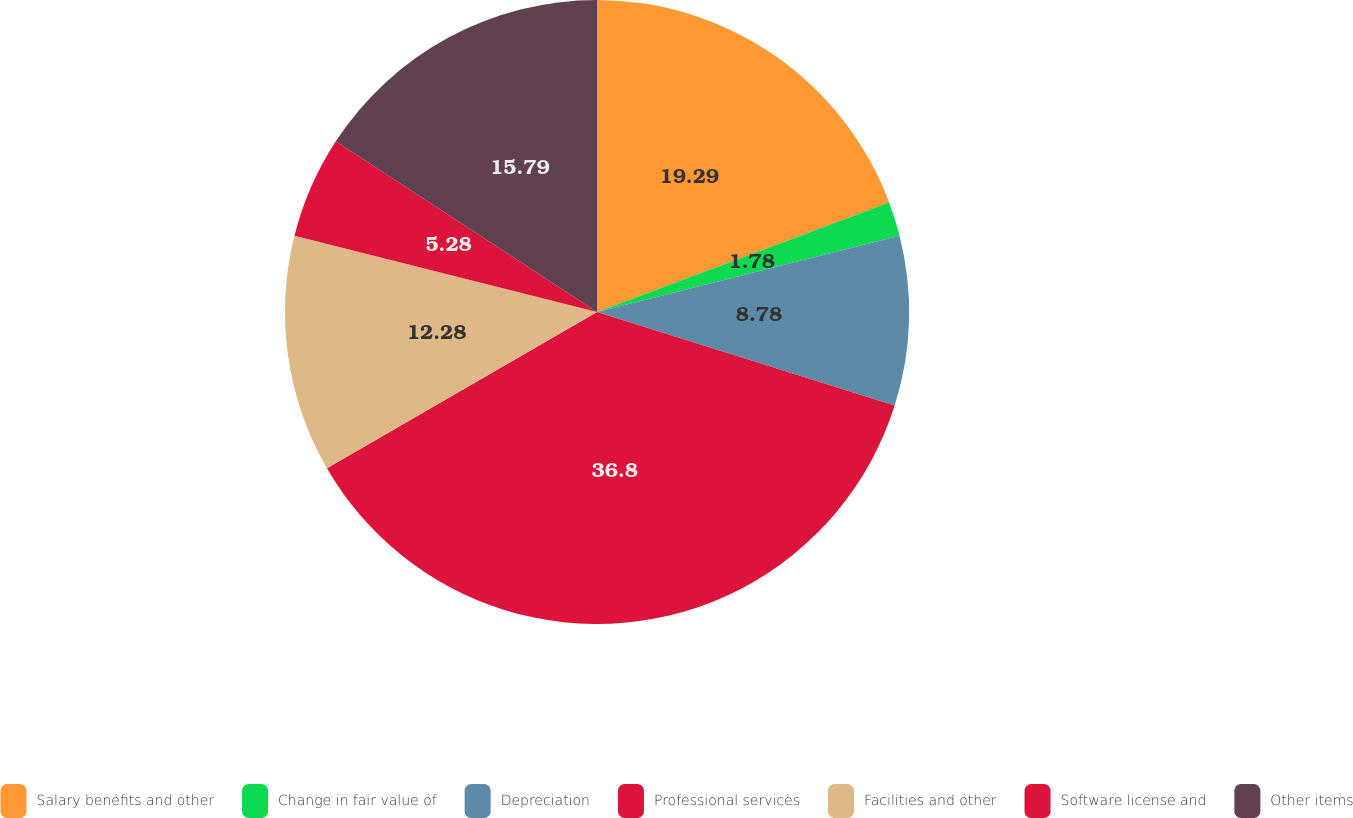<chart> <loc_0><loc_0><loc_500><loc_500><pie_chart><fcel>Salary benefits and other<fcel>Change in fair value of<fcel>Depreciation<fcel>Professional services<fcel>Facilities and other<fcel>Software license and<fcel>Other items<nl><fcel>19.29%<fcel>1.78%<fcel>8.78%<fcel>36.8%<fcel>12.28%<fcel>5.28%<fcel>15.79%<nl></chart> 